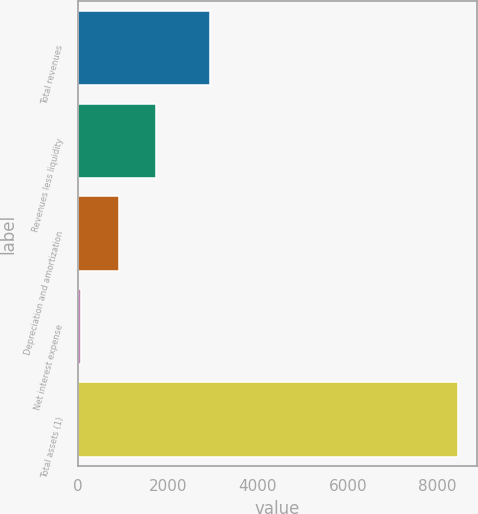<chart> <loc_0><loc_0><loc_500><loc_500><bar_chart><fcel>Total revenues<fcel>Revenues less liquidity<fcel>Depreciation and amortization<fcel>Net interest expense<fcel>Total assets (1)<nl><fcel>2929<fcel>1737.8<fcel>898.4<fcel>59<fcel>8453<nl></chart> 